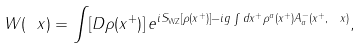Convert formula to latex. <formula><loc_0><loc_0><loc_500><loc_500>W ( \ x ) = \int [ D \rho ( x ^ { + } ) ] \, e ^ { i S _ { \text {WZ} } [ \rho ( x ^ { + } ) ] - i g \int d x ^ { + } \rho ^ { a } ( x ^ { + } ) A ^ { - } _ { a } ( x ^ { + } , \ x ) } ,</formula> 